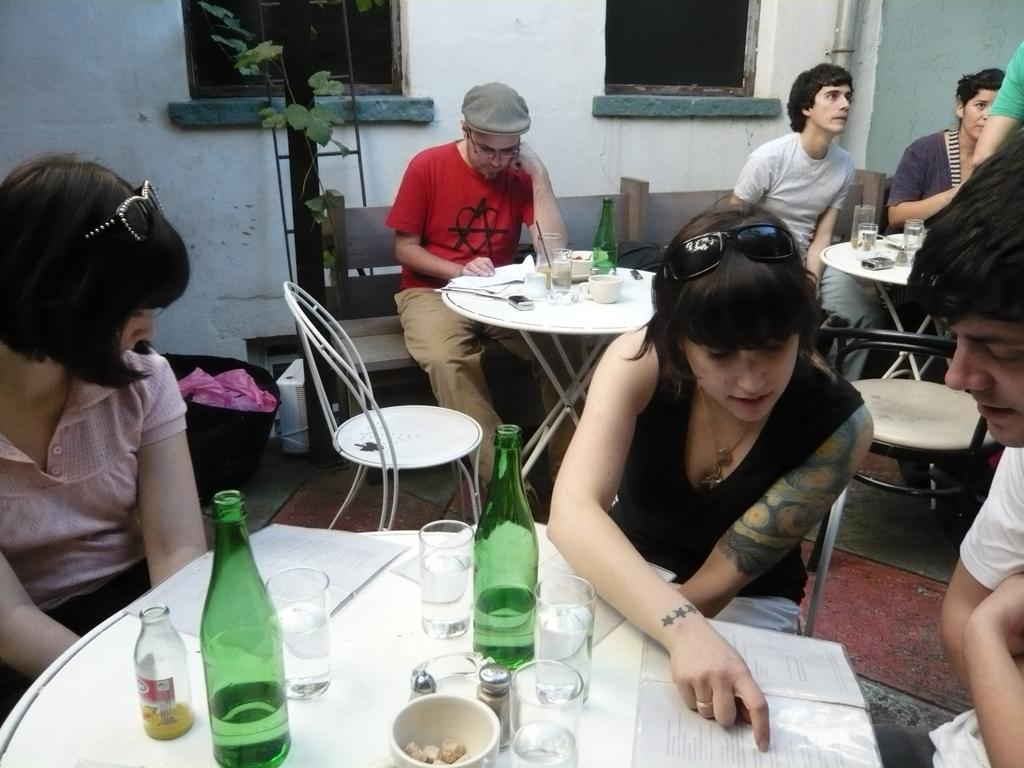What are the people in the image doing? The people in the image are sitting on chairs at a table. What items can be seen on the table? There are wine bottles, glasses, a bowl, and a book on the table. What can be seen in the background of the image? There is a wall, a pole, and a houseplant in the background. What type of stone is being used to build the arm of the chair in the image? There is no mention of a chair with a stone arm in the image. The chairs in the image do not appear to be made of stone. 